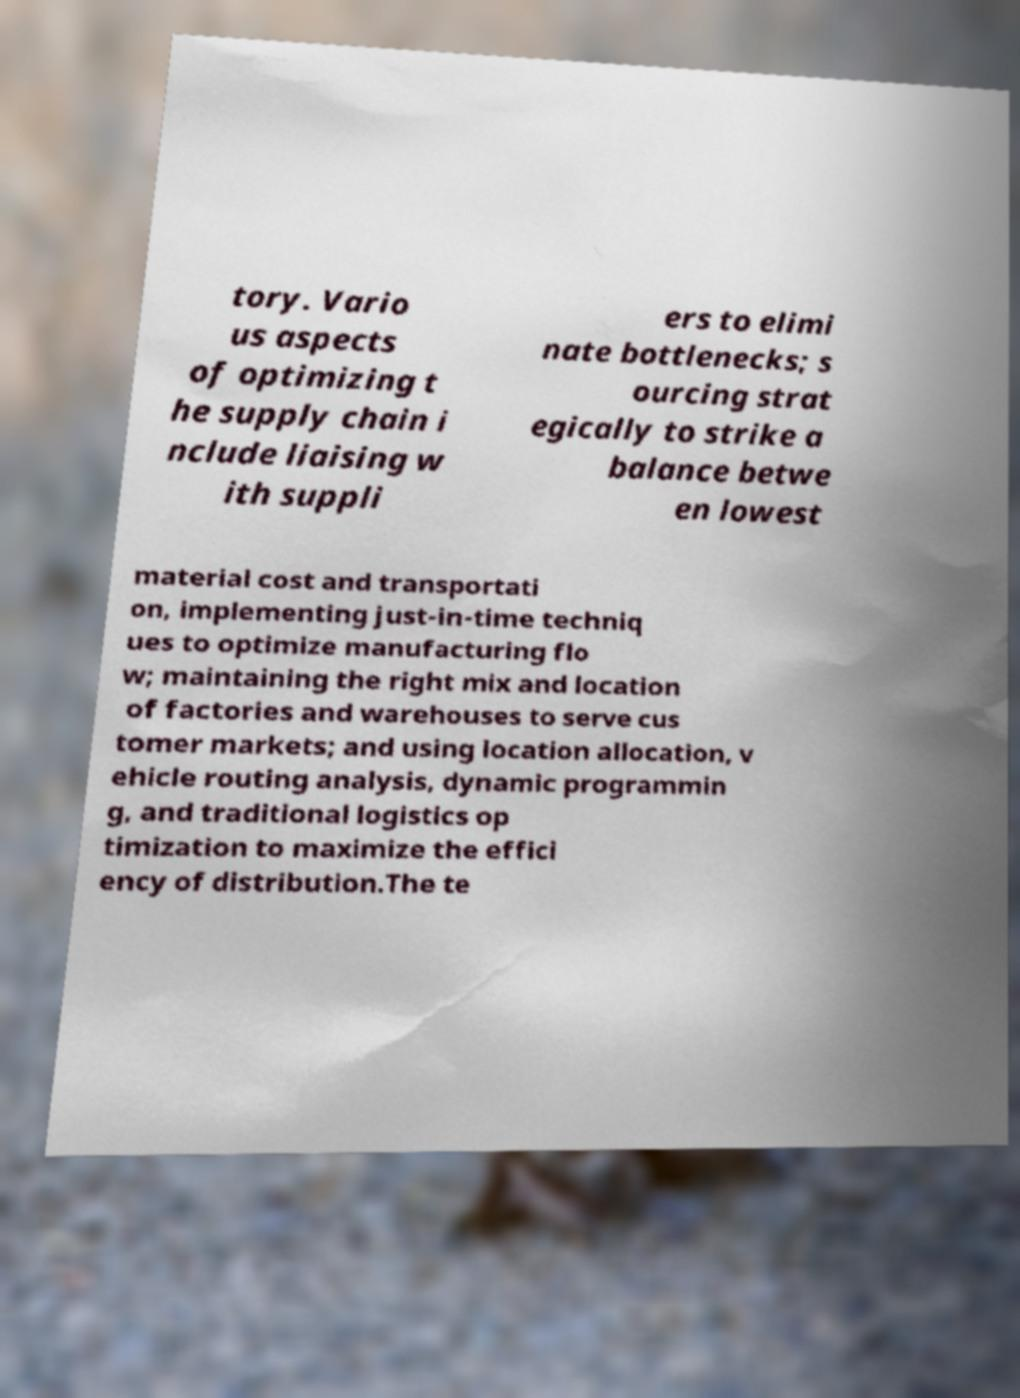I need the written content from this picture converted into text. Can you do that? tory. Vario us aspects of optimizing t he supply chain i nclude liaising w ith suppli ers to elimi nate bottlenecks; s ourcing strat egically to strike a balance betwe en lowest material cost and transportati on, implementing just-in-time techniq ues to optimize manufacturing flo w; maintaining the right mix and location of factories and warehouses to serve cus tomer markets; and using location allocation, v ehicle routing analysis, dynamic programmin g, and traditional logistics op timization to maximize the effici ency of distribution.The te 